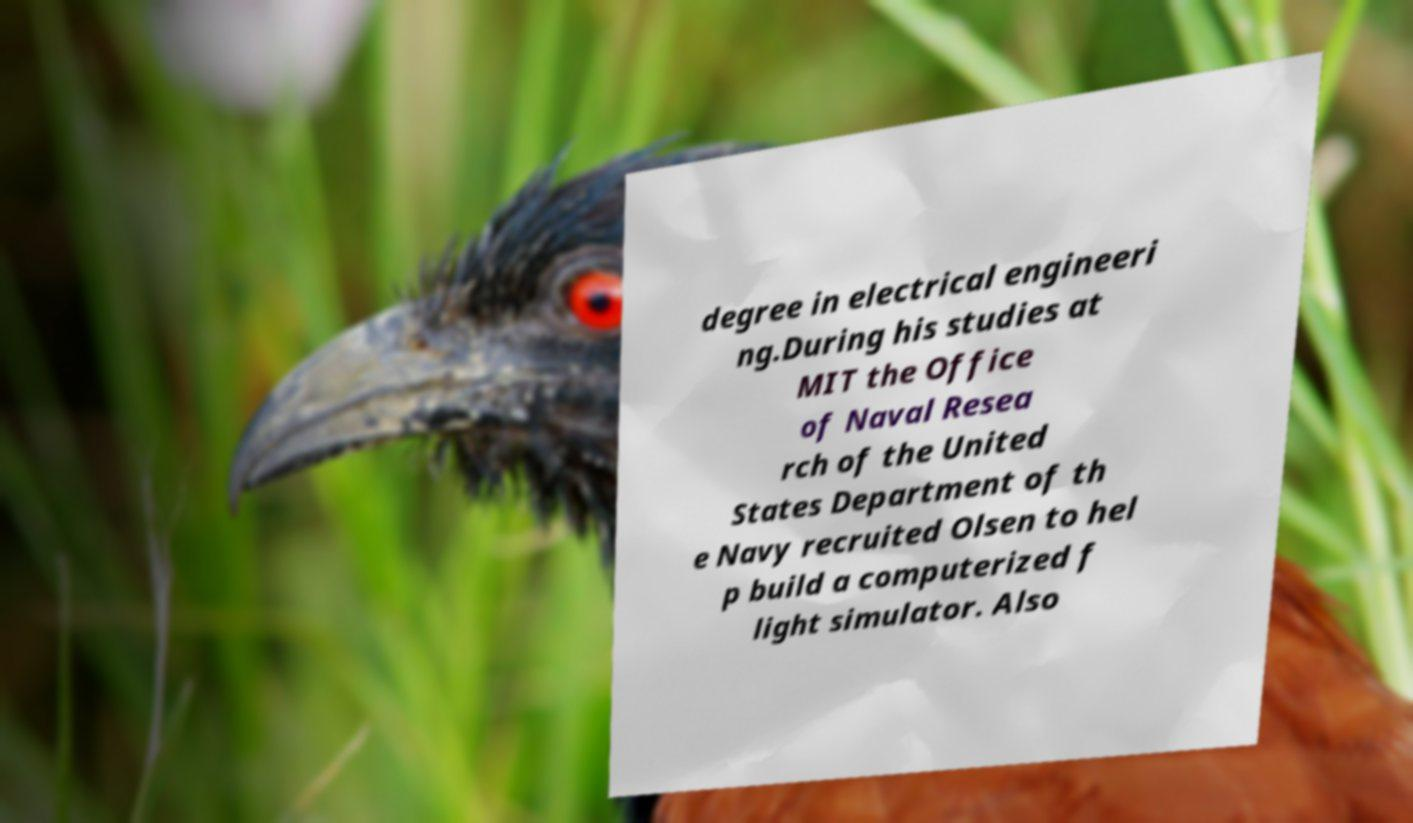Could you extract and type out the text from this image? degree in electrical engineeri ng.During his studies at MIT the Office of Naval Resea rch of the United States Department of th e Navy recruited Olsen to hel p build a computerized f light simulator. Also 